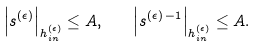Convert formula to latex. <formula><loc_0><loc_0><loc_500><loc_500>\left | s ^ { ( \epsilon ) } \right | _ { h ^ { ( \epsilon ) } _ { i n } } \leq A , \quad \left | s ^ { ( \epsilon ) \, - 1 } \right | _ { h ^ { ( \epsilon ) } _ { i n } } \leq A .</formula> 